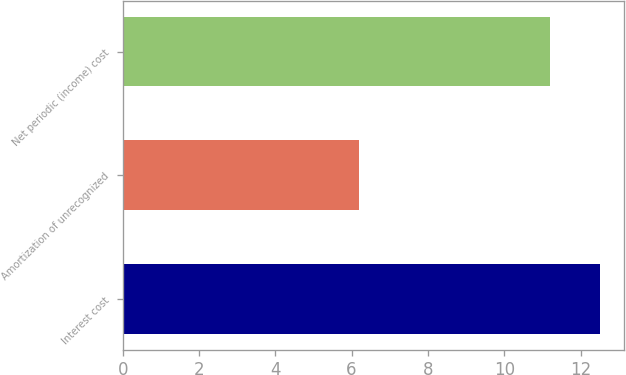Convert chart to OTSL. <chart><loc_0><loc_0><loc_500><loc_500><bar_chart><fcel>Interest cost<fcel>Amortization of unrecognized<fcel>Net periodic (income) cost<nl><fcel>12.5<fcel>6.2<fcel>11.2<nl></chart> 